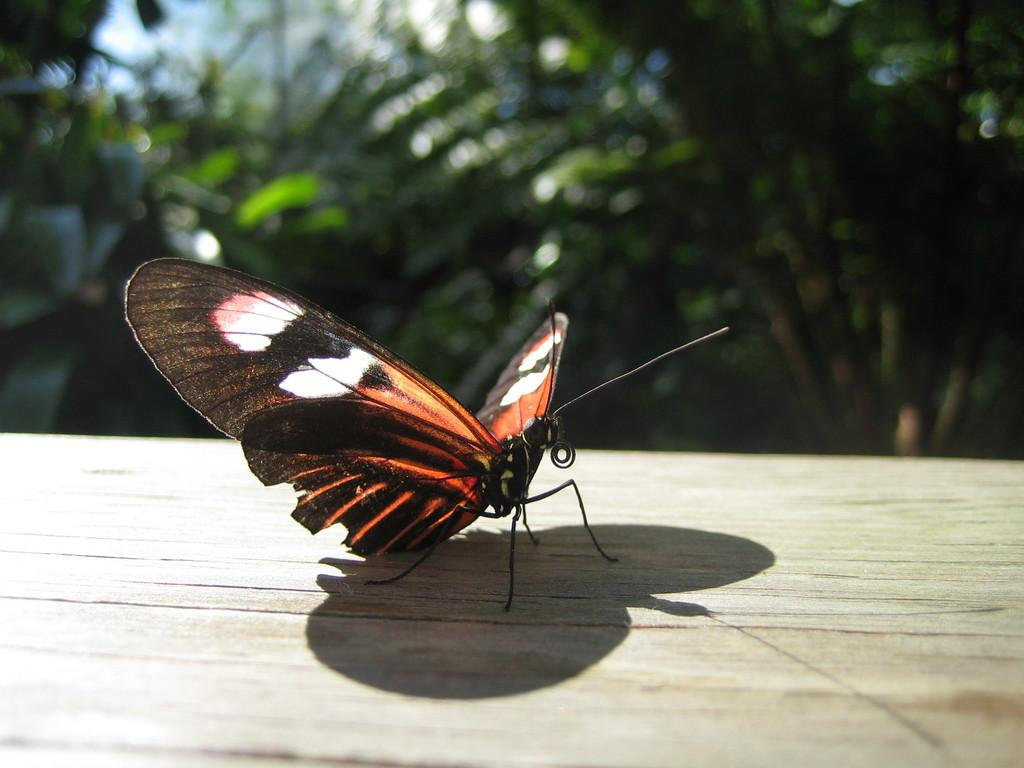What is the main subject of the image? There is a butterfly on a wooden board in the image. Can you describe the background of the image? The top of the image has a blurry view, and there are many plants and trees visible in the image. How many mice can be seen running on the trail in the image? There are no mice or trails present in the image; it features a butterfly on a wooden board with a blurry background of plants and trees. 